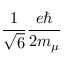<formula> <loc_0><loc_0><loc_500><loc_500>\frac { 1 } { \sqrt { 6 } } \frac { e } { 2 m _ { \mu } }</formula> 